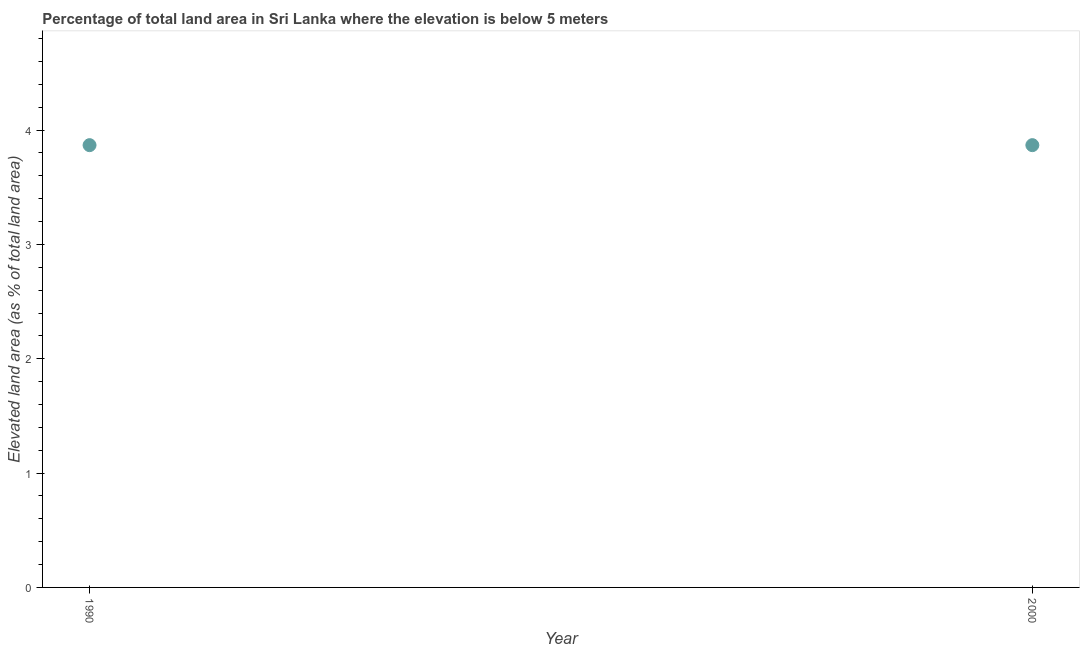What is the total elevated land area in 1990?
Provide a succinct answer. 3.87. Across all years, what is the maximum total elevated land area?
Offer a very short reply. 3.87. Across all years, what is the minimum total elevated land area?
Give a very brief answer. 3.87. In which year was the total elevated land area minimum?
Provide a succinct answer. 1990. What is the sum of the total elevated land area?
Your answer should be very brief. 7.74. What is the average total elevated land area per year?
Offer a very short reply. 3.87. What is the median total elevated land area?
Your answer should be very brief. 3.87. In how many years, is the total elevated land area greater than 2.6 %?
Give a very brief answer. 2. Is the total elevated land area in 1990 less than that in 2000?
Keep it short and to the point. No. How many years are there in the graph?
Keep it short and to the point. 2. What is the difference between two consecutive major ticks on the Y-axis?
Give a very brief answer. 1. Are the values on the major ticks of Y-axis written in scientific E-notation?
Provide a short and direct response. No. Does the graph contain any zero values?
Provide a succinct answer. No. What is the title of the graph?
Your answer should be very brief. Percentage of total land area in Sri Lanka where the elevation is below 5 meters. What is the label or title of the Y-axis?
Your response must be concise. Elevated land area (as % of total land area). What is the Elevated land area (as % of total land area) in 1990?
Keep it short and to the point. 3.87. What is the Elevated land area (as % of total land area) in 2000?
Make the answer very short. 3.87. What is the ratio of the Elevated land area (as % of total land area) in 1990 to that in 2000?
Your answer should be compact. 1. 